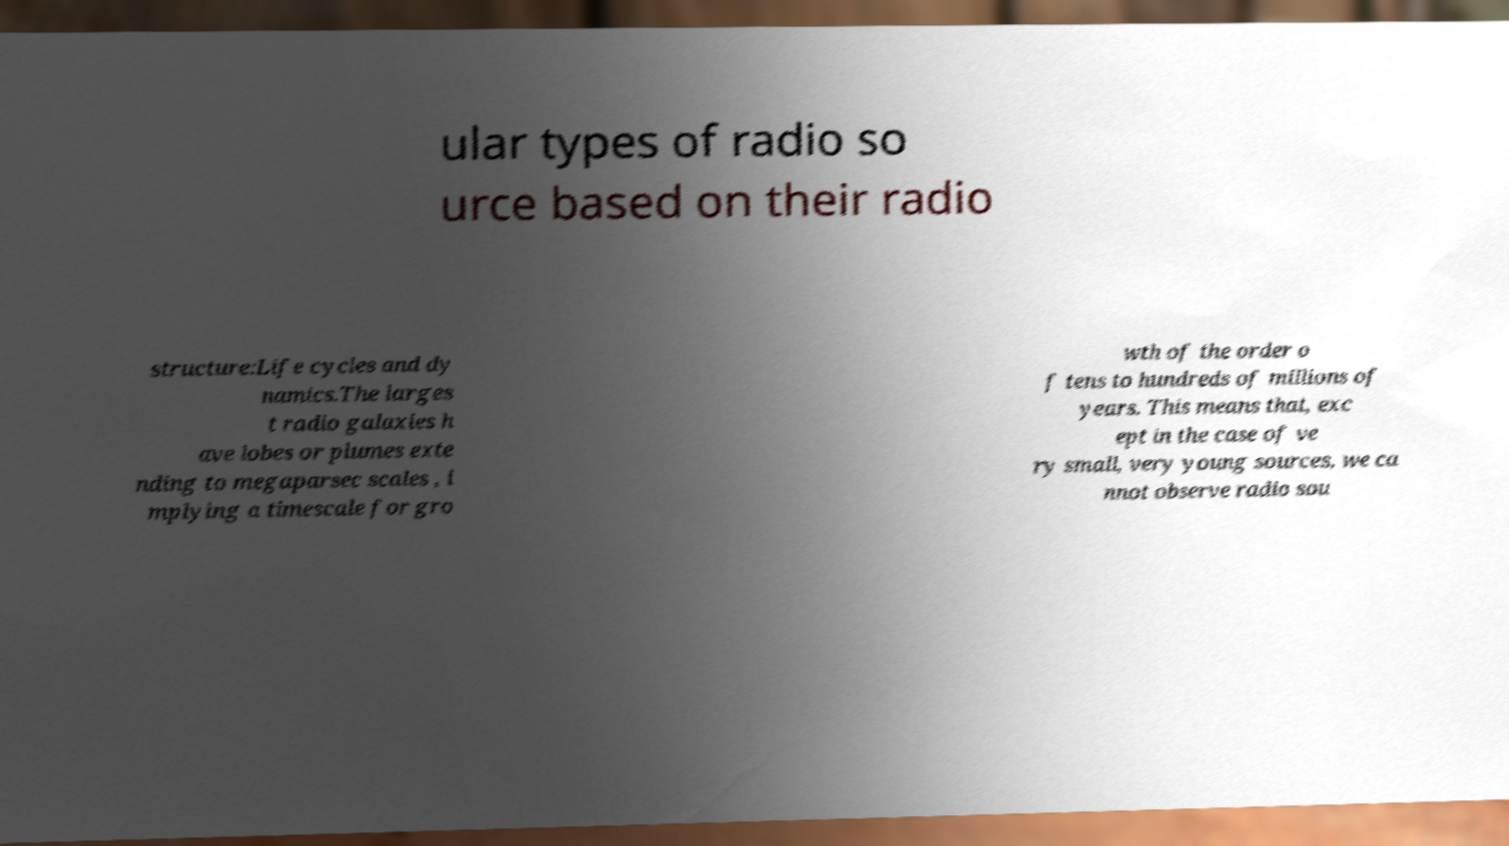What messages or text are displayed in this image? I need them in a readable, typed format. ular types of radio so urce based on their radio structure:Life cycles and dy namics.The larges t radio galaxies h ave lobes or plumes exte nding to megaparsec scales , i mplying a timescale for gro wth of the order o f tens to hundreds of millions of years. This means that, exc ept in the case of ve ry small, very young sources, we ca nnot observe radio sou 